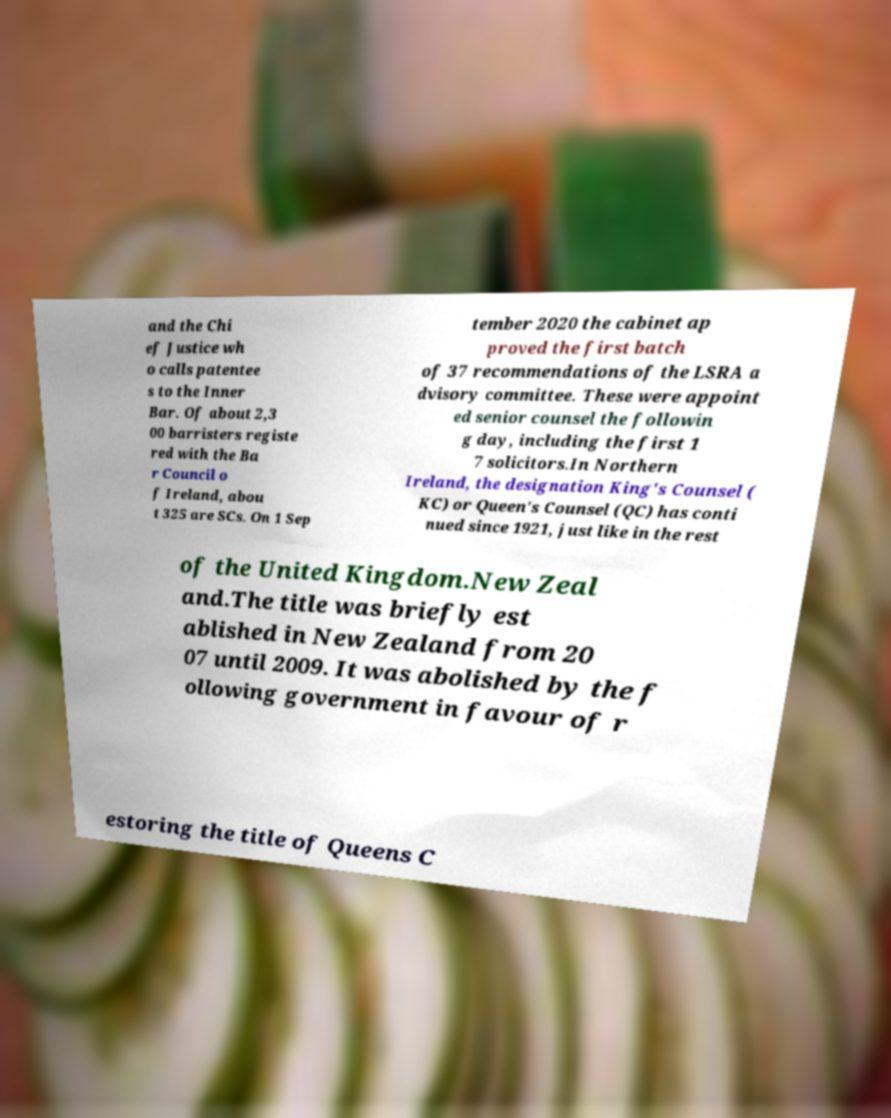Could you assist in decoding the text presented in this image and type it out clearly? and the Chi ef Justice wh o calls patentee s to the Inner Bar. Of about 2,3 00 barristers registe red with the Ba r Council o f Ireland, abou t 325 are SCs. On 1 Sep tember 2020 the cabinet ap proved the first batch of 37 recommendations of the LSRA a dvisory committee. These were appoint ed senior counsel the followin g day, including the first 1 7 solicitors.In Northern Ireland, the designation King's Counsel ( KC) or Queen's Counsel (QC) has conti nued since 1921, just like in the rest of the United Kingdom.New Zeal and.The title was briefly est ablished in New Zealand from 20 07 until 2009. It was abolished by the f ollowing government in favour of r estoring the title of Queens C 